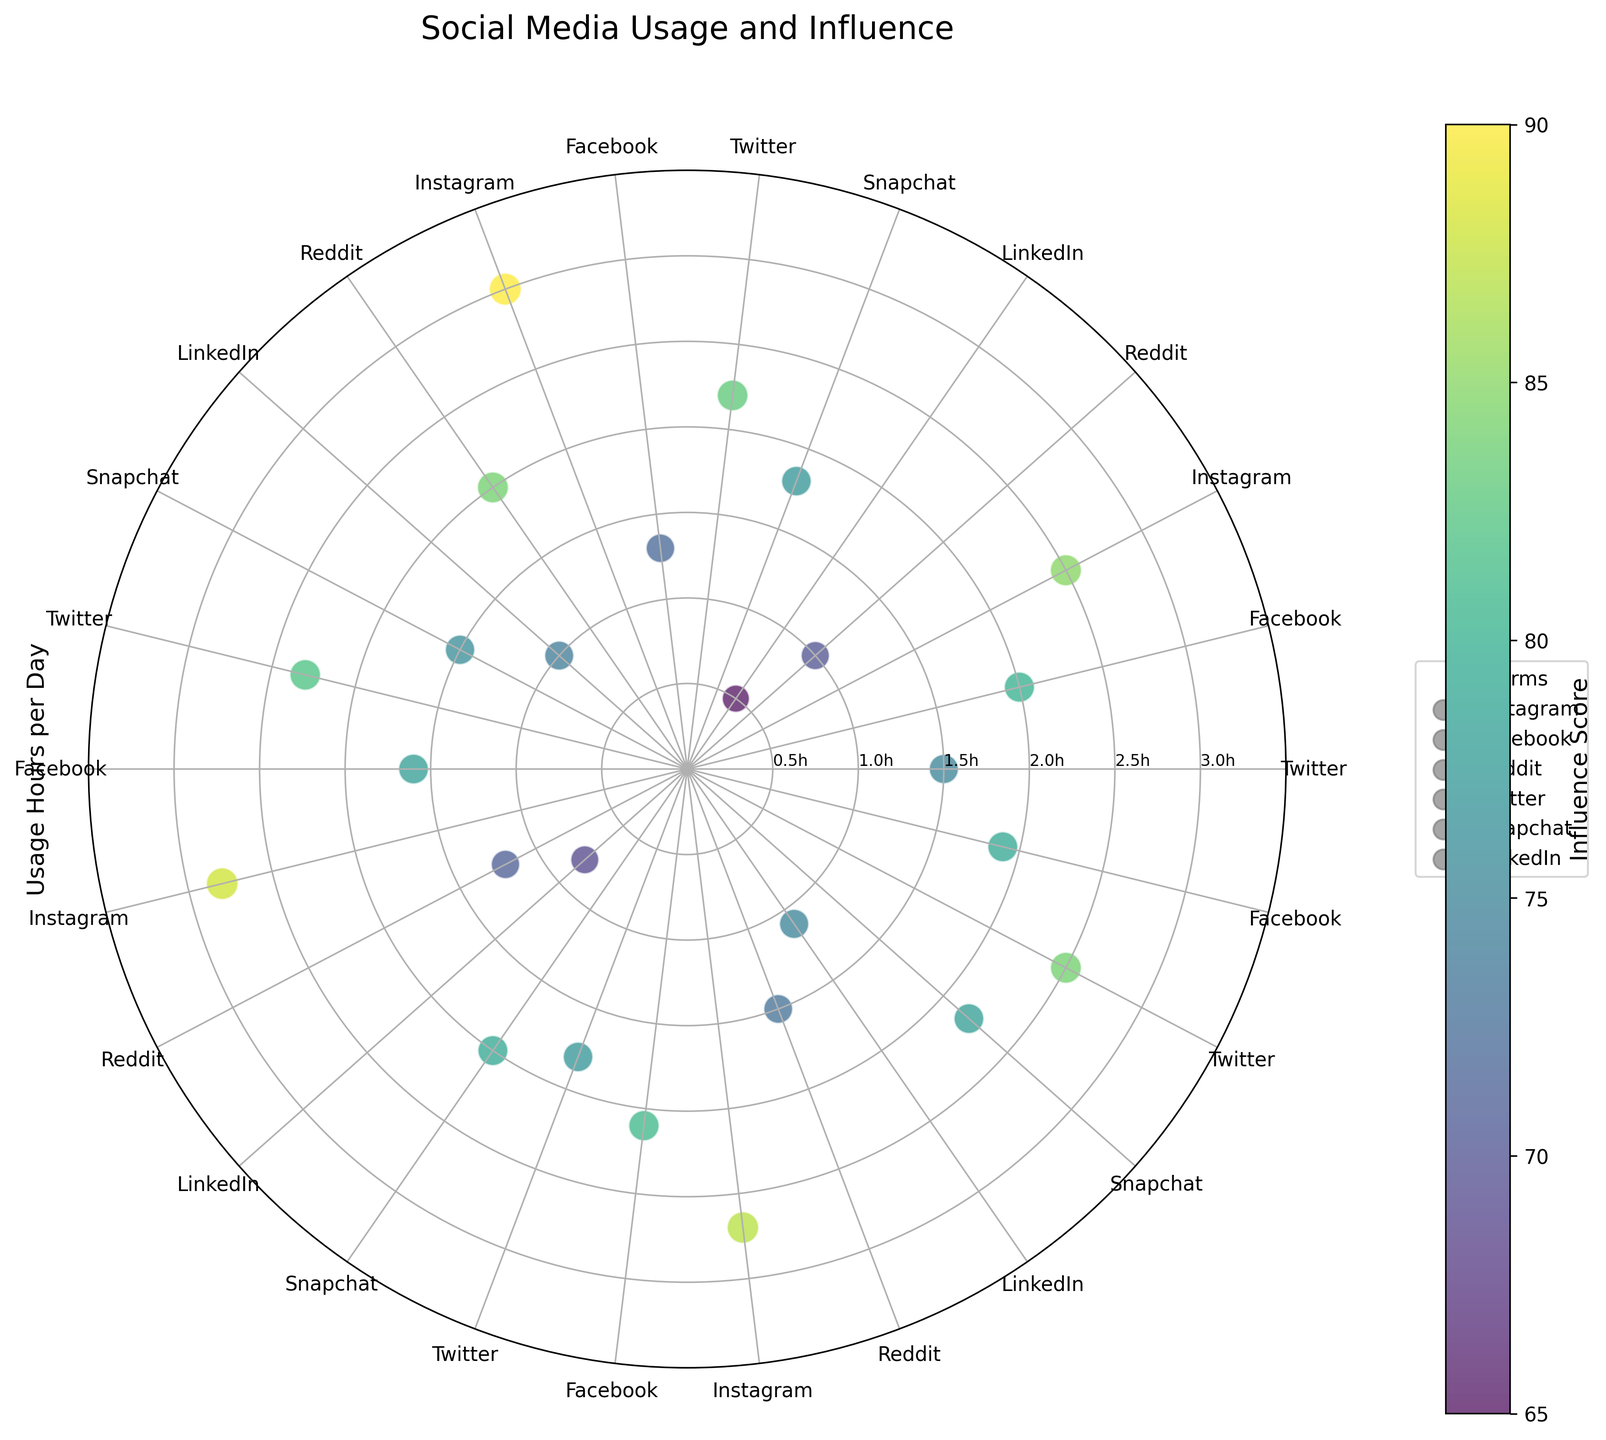What is the title of the figure? The title is located at the top of the figure, providing an overview of what the figure represents.
Answer: Social Media Usage and Influence Which platform has the highest usage hours per day and what are those hours? To find this, locate the longest radial distance from the center (maximum usage hours), and then check the corresponding platform along the angular position.
Answer: Instagram, 3.0 hours What is the influence score range shown in the figure? This can be determined by looking at the colorbar on the side of the figure, which indicates the range from the minimum to the maximum influence score.
Answer: 65 to 90 How many data points are there for the platform "Twitter"? Identify the number of angular points labeled "Twitter" and count the corresponding data points.
Answer: 5 Which platform shows the largest variation in usage hours per day? Determine this by visually inspecting the spread of data points radially for each platform and comparing the ranges.
Answer: Instagram What is the average influence score for data points associated with "Reddit"? Find all data points for "Reddit", sum their influence scores, and divide by the number of these points: (70 + 84 + 71 + 73) / 4.
Answer: 74.5 Compare the influence scores of Facebook and Snapchat users. Which platform's users have higher average influence scores? Calculate the average influence scores for each platform and compare: Facebook (80 + 72 + 78 + 81 + 79) / 5 and Snapchat (77 + 76 + 79 + 78) / 4.
Answer: Facebook, 78 Which social media platform shows the data point with the lowest usage hours per day? Identify the shortest radial distance from the center (minimum usage hours) and find the associated platform at that point.
Answer: LinkedIn Are there any platforms that consistently have high influence scores (above 80)? If so, which ones? Check all data points with influence scores above 80 and identify if certain platforms have multiple data points meeting this criterion.
Answer: Instagram, Twitter, Facebook What is the correlation between usage hours per day and influence scores for "Instagram"? Observe the pattern of "Instagram" data points; higher usage hours generally correlate with higher influence scores, but a numerical correlation isn't directly drawn from the figure alone.
Answer: Positive correlation 